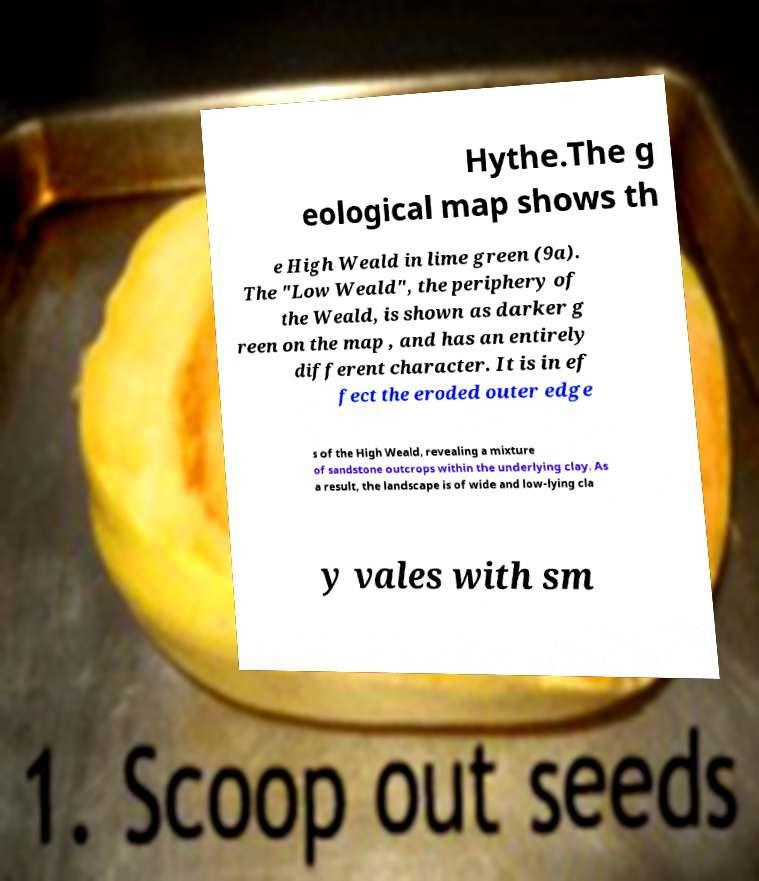I need the written content from this picture converted into text. Can you do that? Hythe.The g eological map shows th e High Weald in lime green (9a). The "Low Weald", the periphery of the Weald, is shown as darker g reen on the map , and has an entirely different character. It is in ef fect the eroded outer edge s of the High Weald, revealing a mixture of sandstone outcrops within the underlying clay. As a result, the landscape is of wide and low-lying cla y vales with sm 